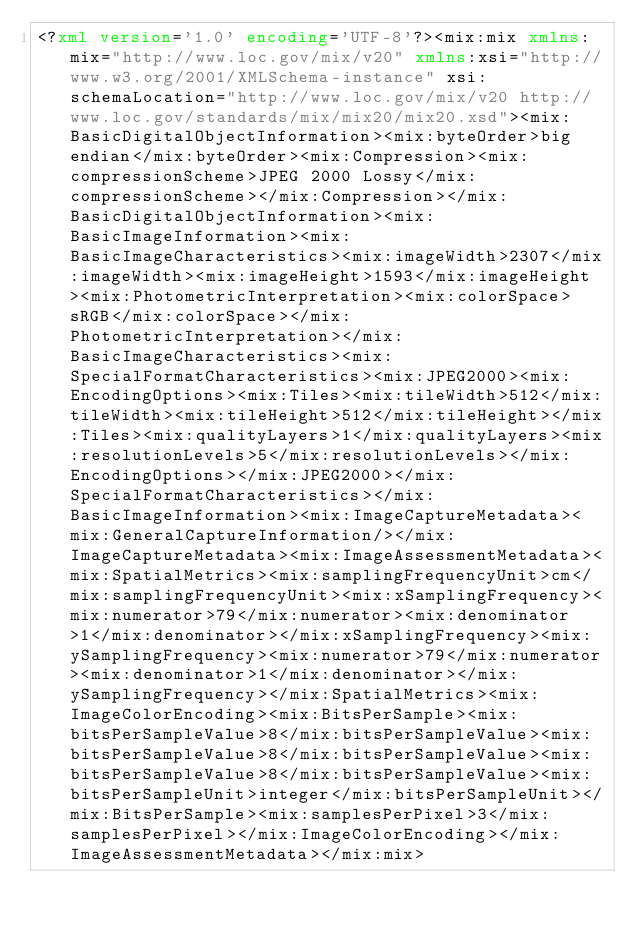Convert code to text. <code><loc_0><loc_0><loc_500><loc_500><_XML_><?xml version='1.0' encoding='UTF-8'?><mix:mix xmlns:mix="http://www.loc.gov/mix/v20" xmlns:xsi="http://www.w3.org/2001/XMLSchema-instance" xsi:schemaLocation="http://www.loc.gov/mix/v20 http://www.loc.gov/standards/mix/mix20/mix20.xsd"><mix:BasicDigitalObjectInformation><mix:byteOrder>big endian</mix:byteOrder><mix:Compression><mix:compressionScheme>JPEG 2000 Lossy</mix:compressionScheme></mix:Compression></mix:BasicDigitalObjectInformation><mix:BasicImageInformation><mix:BasicImageCharacteristics><mix:imageWidth>2307</mix:imageWidth><mix:imageHeight>1593</mix:imageHeight><mix:PhotometricInterpretation><mix:colorSpace>sRGB</mix:colorSpace></mix:PhotometricInterpretation></mix:BasicImageCharacteristics><mix:SpecialFormatCharacteristics><mix:JPEG2000><mix:EncodingOptions><mix:Tiles><mix:tileWidth>512</mix:tileWidth><mix:tileHeight>512</mix:tileHeight></mix:Tiles><mix:qualityLayers>1</mix:qualityLayers><mix:resolutionLevels>5</mix:resolutionLevels></mix:EncodingOptions></mix:JPEG2000></mix:SpecialFormatCharacteristics></mix:BasicImageInformation><mix:ImageCaptureMetadata><mix:GeneralCaptureInformation/></mix:ImageCaptureMetadata><mix:ImageAssessmentMetadata><mix:SpatialMetrics><mix:samplingFrequencyUnit>cm</mix:samplingFrequencyUnit><mix:xSamplingFrequency><mix:numerator>79</mix:numerator><mix:denominator>1</mix:denominator></mix:xSamplingFrequency><mix:ySamplingFrequency><mix:numerator>79</mix:numerator><mix:denominator>1</mix:denominator></mix:ySamplingFrequency></mix:SpatialMetrics><mix:ImageColorEncoding><mix:BitsPerSample><mix:bitsPerSampleValue>8</mix:bitsPerSampleValue><mix:bitsPerSampleValue>8</mix:bitsPerSampleValue><mix:bitsPerSampleValue>8</mix:bitsPerSampleValue><mix:bitsPerSampleUnit>integer</mix:bitsPerSampleUnit></mix:BitsPerSample><mix:samplesPerPixel>3</mix:samplesPerPixel></mix:ImageColorEncoding></mix:ImageAssessmentMetadata></mix:mix></code> 